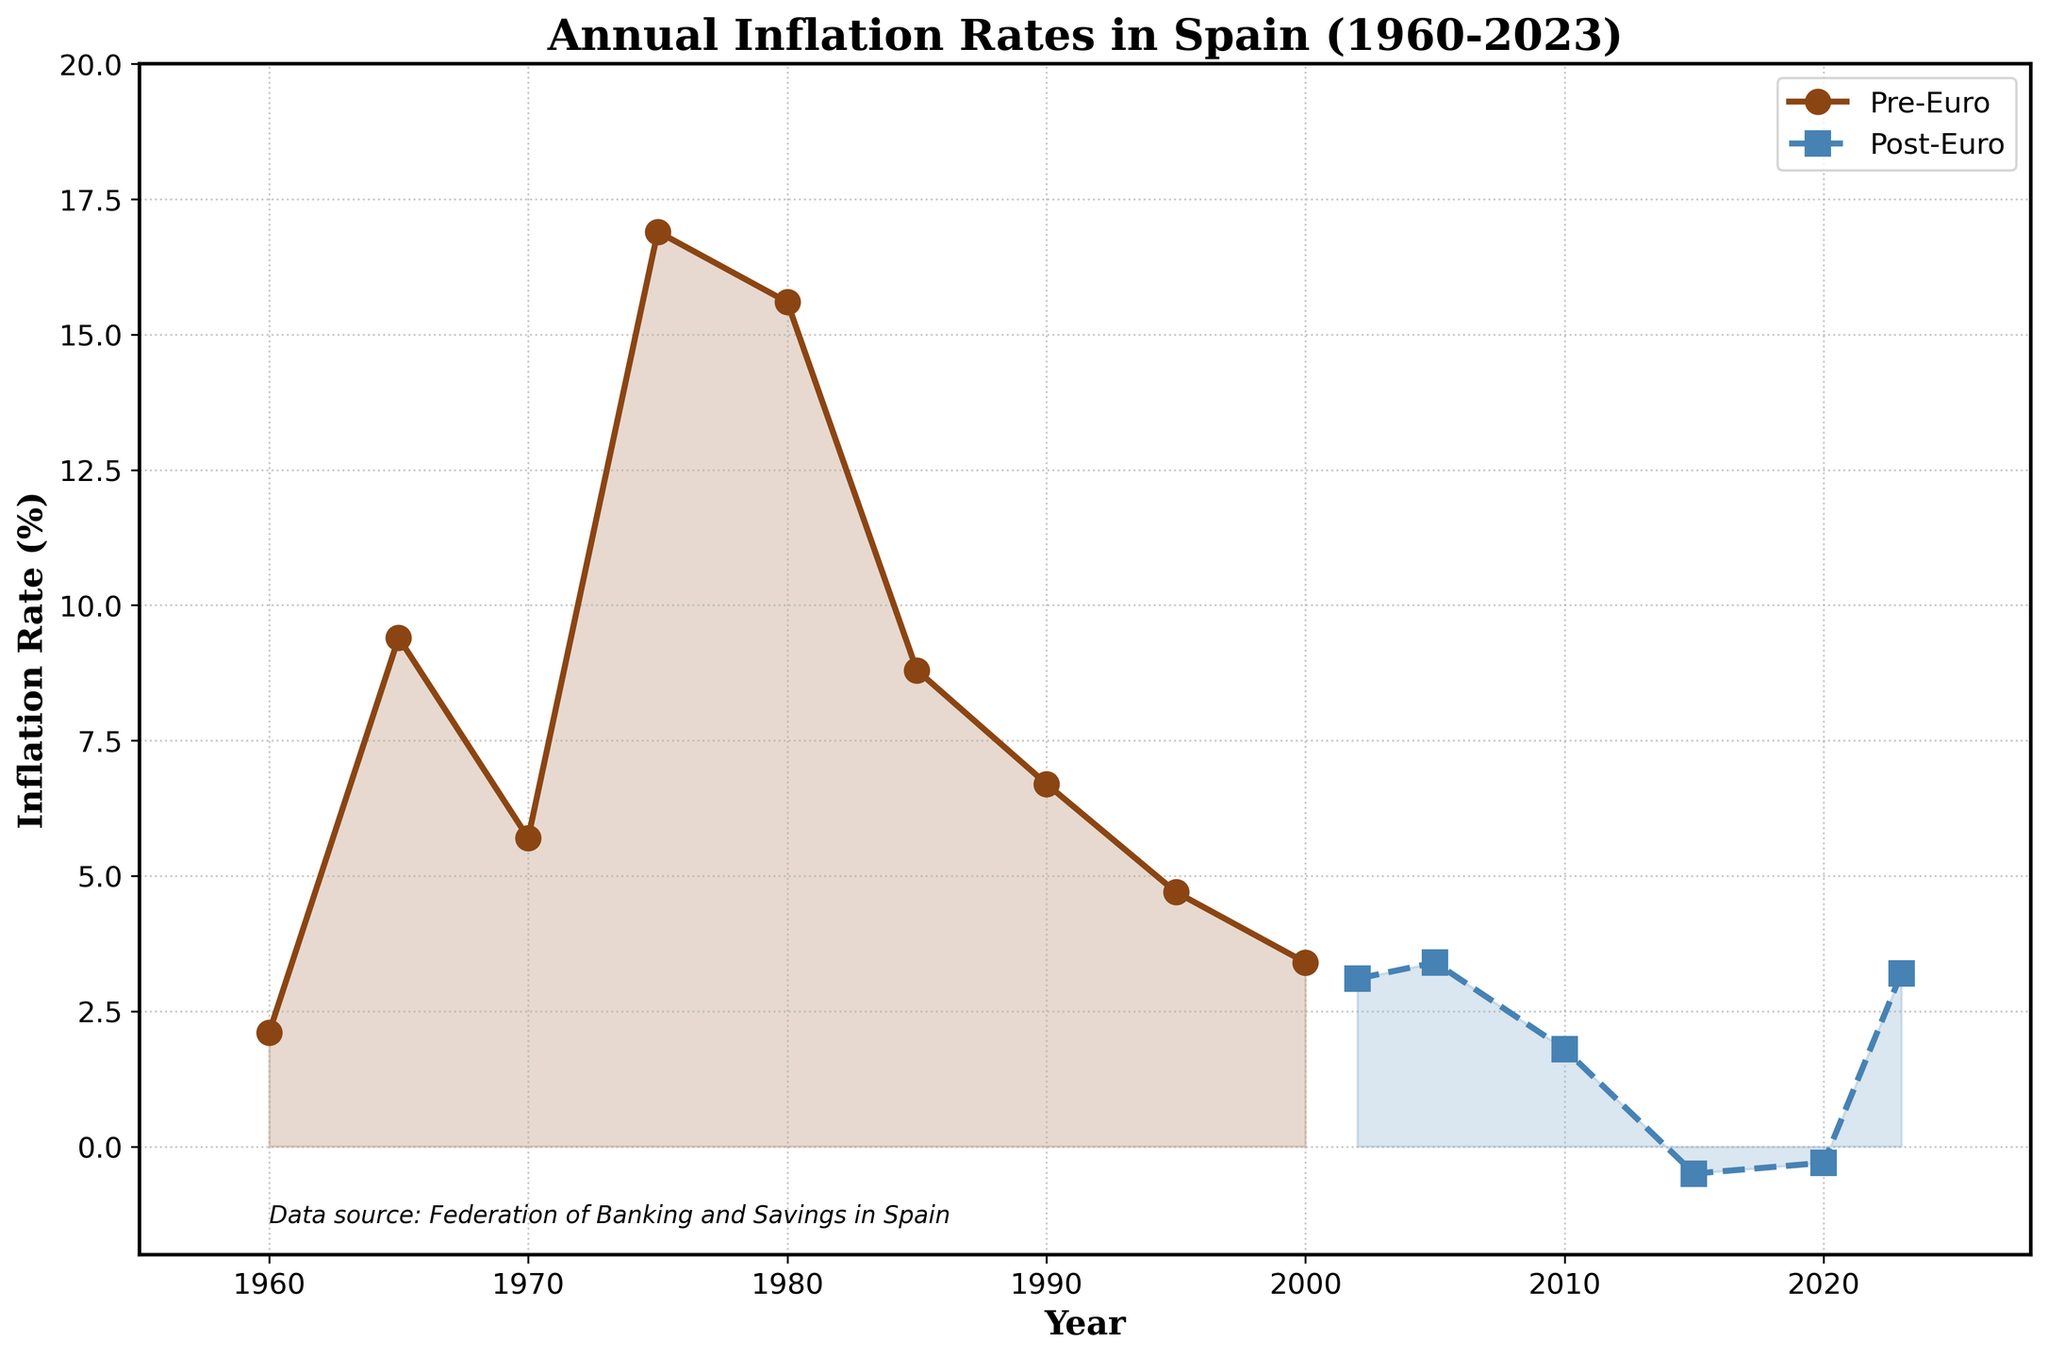What was the inflation rate in Spain in the year 1980? The figure shows the inflation rates for different years. According to the chart, the inflation rate in 1980 is marked and labeled.
Answer: 15.6% How has the inflation rate changed from 1975 to 1980? To determine the change in inflation rate from 1975 to 1980, subtract the inflation rate in 1975 from the inflation rate in 1980. The rate in 1975 is 16.9% and in 1980 it is 15.6%. 15.6% - 16.9% = -1.3%. The inflation rate decreased by 1.3%.
Answer: Decreased by 1.3% Compare the inflation rate in the year 1995 with the year 2002. Which period had a higher rate? The figure shows that in 1995 the inflation rate was 4.7%, and in 2002 it was 3.1%. Comparing these, we see that the rate in 1995 was higher than in 2002.
Answer: 1995 What is the average inflation rate during the pre-Euro period? To find the average inflation rate during the pre-Euro period, sum up all the inflation rates for the years in the Pre-Euro period and divide by the number of years. The rates are 2.1, 9.4, 5.7, 16.9, 15.6, 8.8, 6.7, 4.7, 3.4. Adding these gives 73.3, and there are 9 years. The average rate is 73.3 / 9 = 8.14.
Answer: 8.14% Looking at the visual representation of inflation rates, during which period (Pre-Euro or Post-Euro) were rates generally higher? By visually comparing the heights of the line segments for the Pre-Euro and Post-Euro periods, it is evident that the inflation rates were generally higher during the Pre-Euro period as the line is mostly above the levels seen in the Post-Euro period.
Answer: Pre-Euro In which year did Spain experience negative inflation rates, and which period does it belong to? The figure shows that negative inflation rates appear around 2015 and 2020. Both of these years belong to the Post-Euro period.
Answer: 2015, Post-Euro What is the main color used to represent the Post-Euro period in the line chart? According to the visual attributes, the Post-Euro period is represented by a dashed blue line with square markers.
Answer: Blue What year marks the first increase in inflation after Spain adopted the Euro? Observing the Post-Euro period line, the first increase can be seen from 2005 to 2010, where the inflation rate increased from 3.4% to 1.8%. Therefore, 2005 is the year that marks the first increase after adopting the Euro in 2002.
Answer: 2005 By how much did the inflation rate change from 2015 to 2023? According to the figure, the inflation rates in 2015 and 2023 are -0.5% and 3.2%, respectively. To find the change, subtract the 2015 rate from the 2023 rate: 3.2% - (-0.5%) = 3.2% + 0.5% = 3.7%.
Answer: Increased by 3.7% 